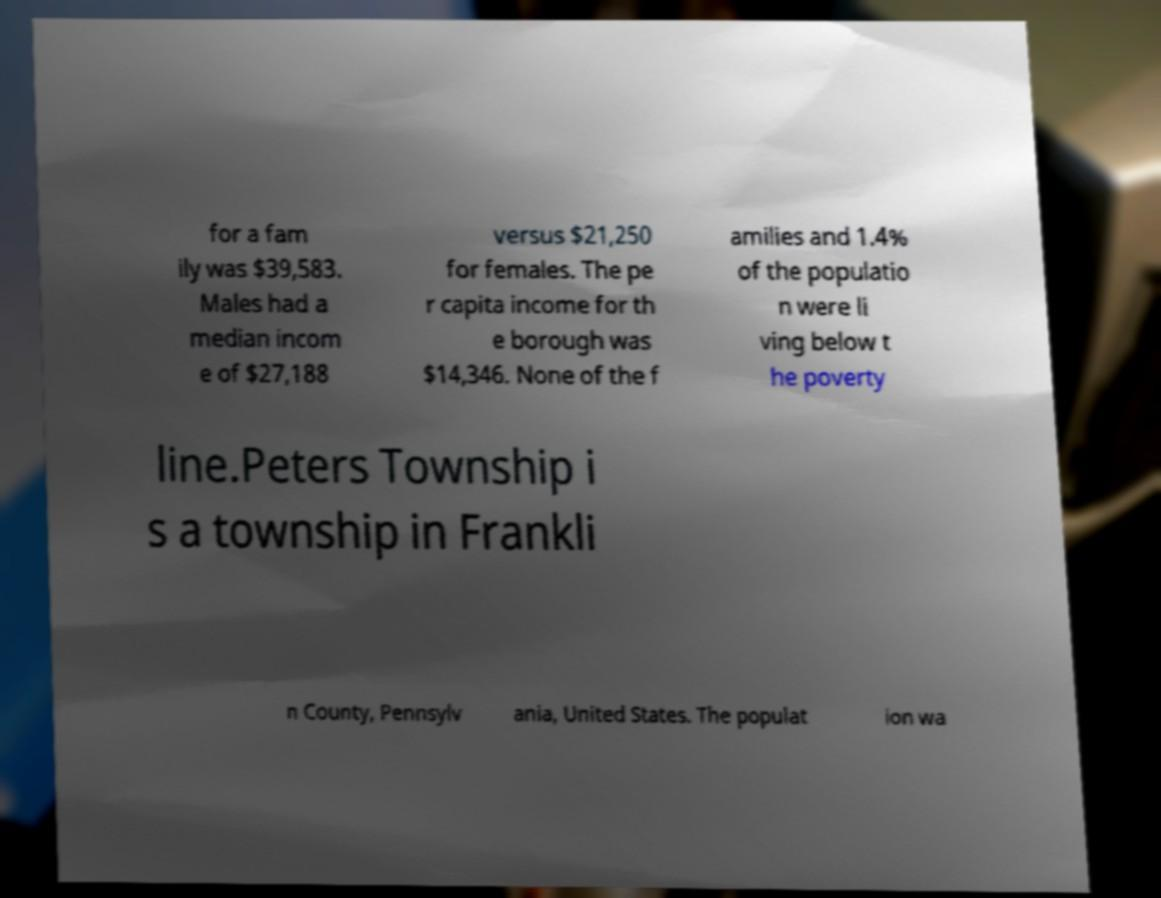There's text embedded in this image that I need extracted. Can you transcribe it verbatim? for a fam ily was $39,583. Males had a median incom e of $27,188 versus $21,250 for females. The pe r capita income for th e borough was $14,346. None of the f amilies and 1.4% of the populatio n were li ving below t he poverty line.Peters Township i s a township in Frankli n County, Pennsylv ania, United States. The populat ion wa 